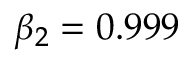<formula> <loc_0><loc_0><loc_500><loc_500>\beta _ { 2 } = 0 . 9 9 9</formula> 